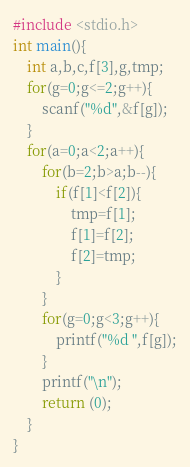<code> <loc_0><loc_0><loc_500><loc_500><_C_>#include <stdio.h>
int main(){
    int a,b,c,f[3],g,tmp;
    for(g=0;g<=2;g++){
        scanf("%d",&f[g]);
    }
    for(a=0;a<2;a++){
        for(b=2;b>a;b--){
            if(f[1]<f[2]){
                tmp=f[1];
                f[1]=f[2];
                f[2]=tmp;
            }
        }
        for(g=0;g<3;g++){
            printf("%d ",f[g]);
        }
        printf("\n");
        return (0);
    }
}</code> 